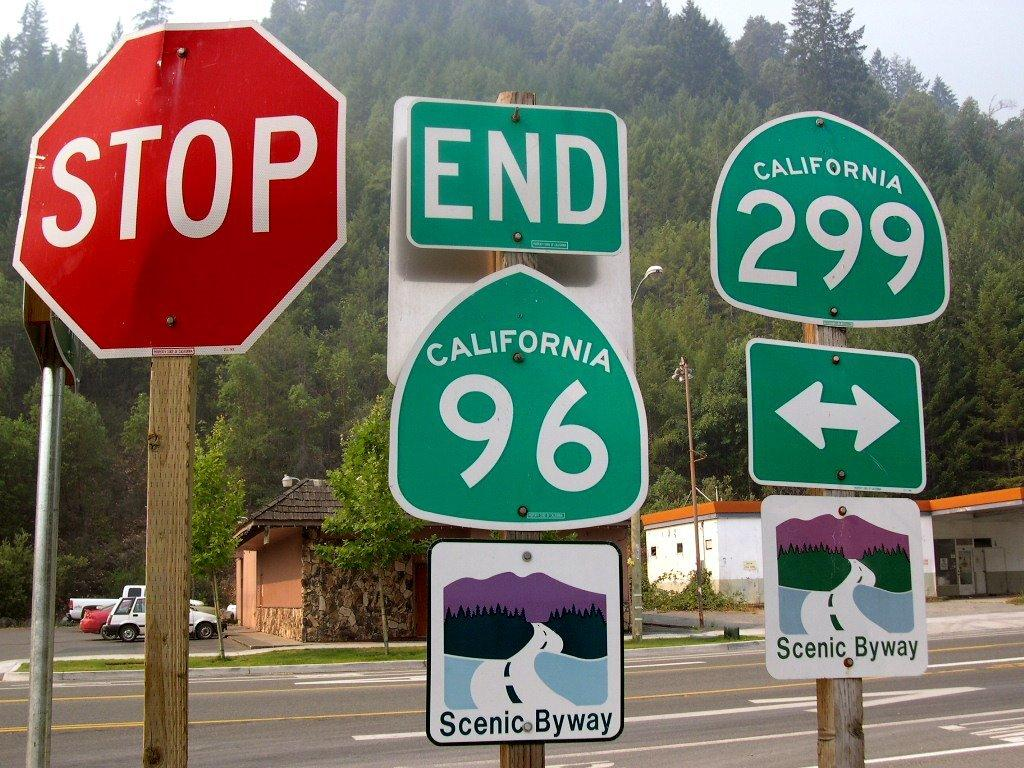What is attached to the poles in the image? There are boards on the poles in the image. What can be seen in the distance behind the poles? There are vehicles, trees, poles, buildings, and clouds visible in the background of the image. Can you see a cactus growing on the chin of the person in the image? There is no person present in the image, and therefore no chin or cactus can be observed. 